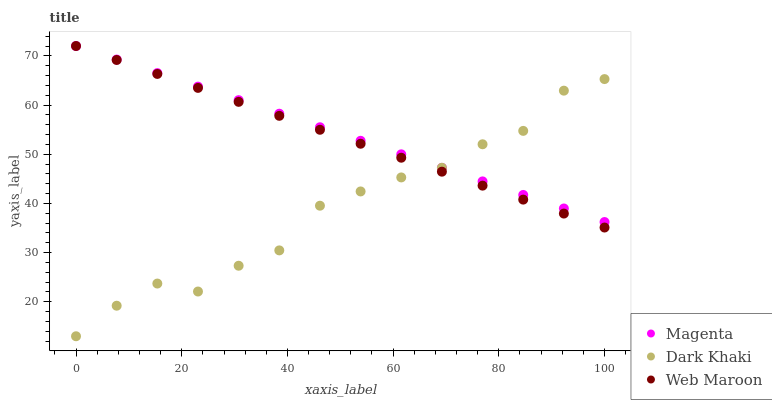Does Dark Khaki have the minimum area under the curve?
Answer yes or no. Yes. Does Magenta have the maximum area under the curve?
Answer yes or no. Yes. Does Web Maroon have the minimum area under the curve?
Answer yes or no. No. Does Web Maroon have the maximum area under the curve?
Answer yes or no. No. Is Magenta the smoothest?
Answer yes or no. Yes. Is Dark Khaki the roughest?
Answer yes or no. Yes. Is Web Maroon the smoothest?
Answer yes or no. No. Is Web Maroon the roughest?
Answer yes or no. No. Does Dark Khaki have the lowest value?
Answer yes or no. Yes. Does Web Maroon have the lowest value?
Answer yes or no. No. Does Web Maroon have the highest value?
Answer yes or no. Yes. Does Dark Khaki intersect Magenta?
Answer yes or no. Yes. Is Dark Khaki less than Magenta?
Answer yes or no. No. Is Dark Khaki greater than Magenta?
Answer yes or no. No. 